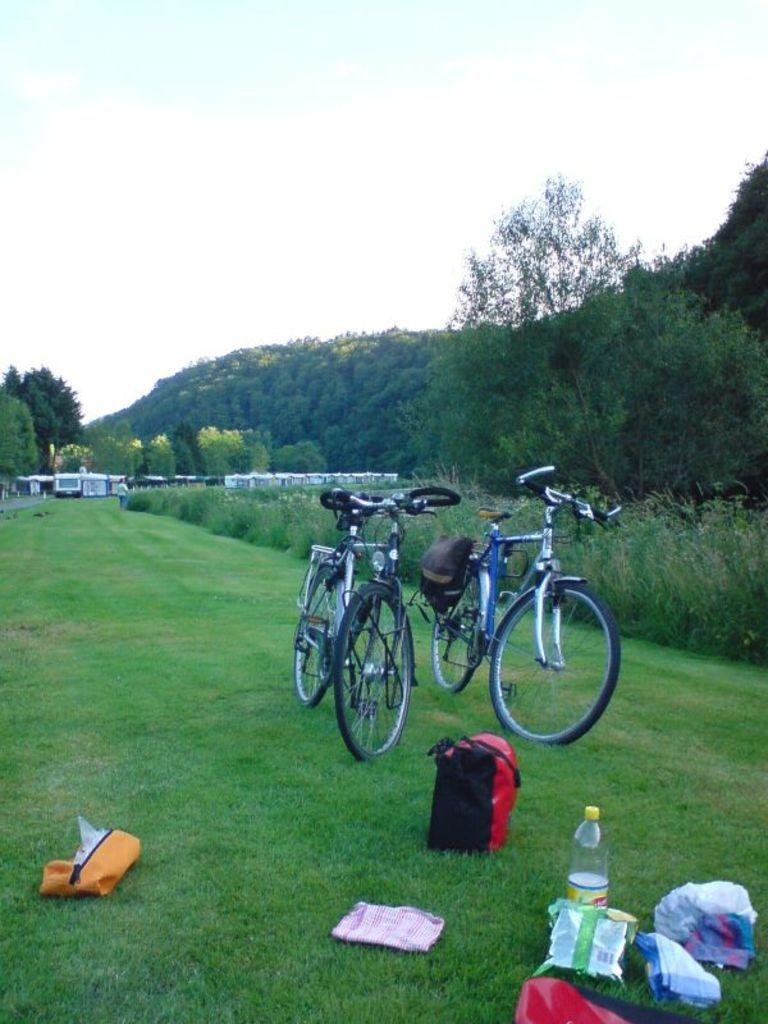What type of vehicles can be seen in the image? There are bicycles and a train in the image. What items are present that might be used for carrying belongings? There are bags and packets in the image. What type of container is visible in the image? There is a bottle in the image. What natural elements can be seen in the image? There is grass, trees, and a hill in the image. What part of the natural environment is visible in the image? The sky is visible in the image. What type of soup is being served in the image? There is no soup present in the image. What type of rock can be seen on the hill in the image? There is no rock visible on the hill in the image. 